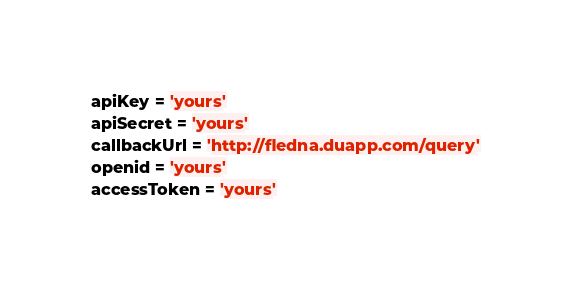<code> <loc_0><loc_0><loc_500><loc_500><_Python_>apiKey = 'yours'
apiSecret = 'yours'
callbackUrl = 'http://fledna.duapp.com/query'
openid = 'yours'
accessToken = 'yours'
</code> 